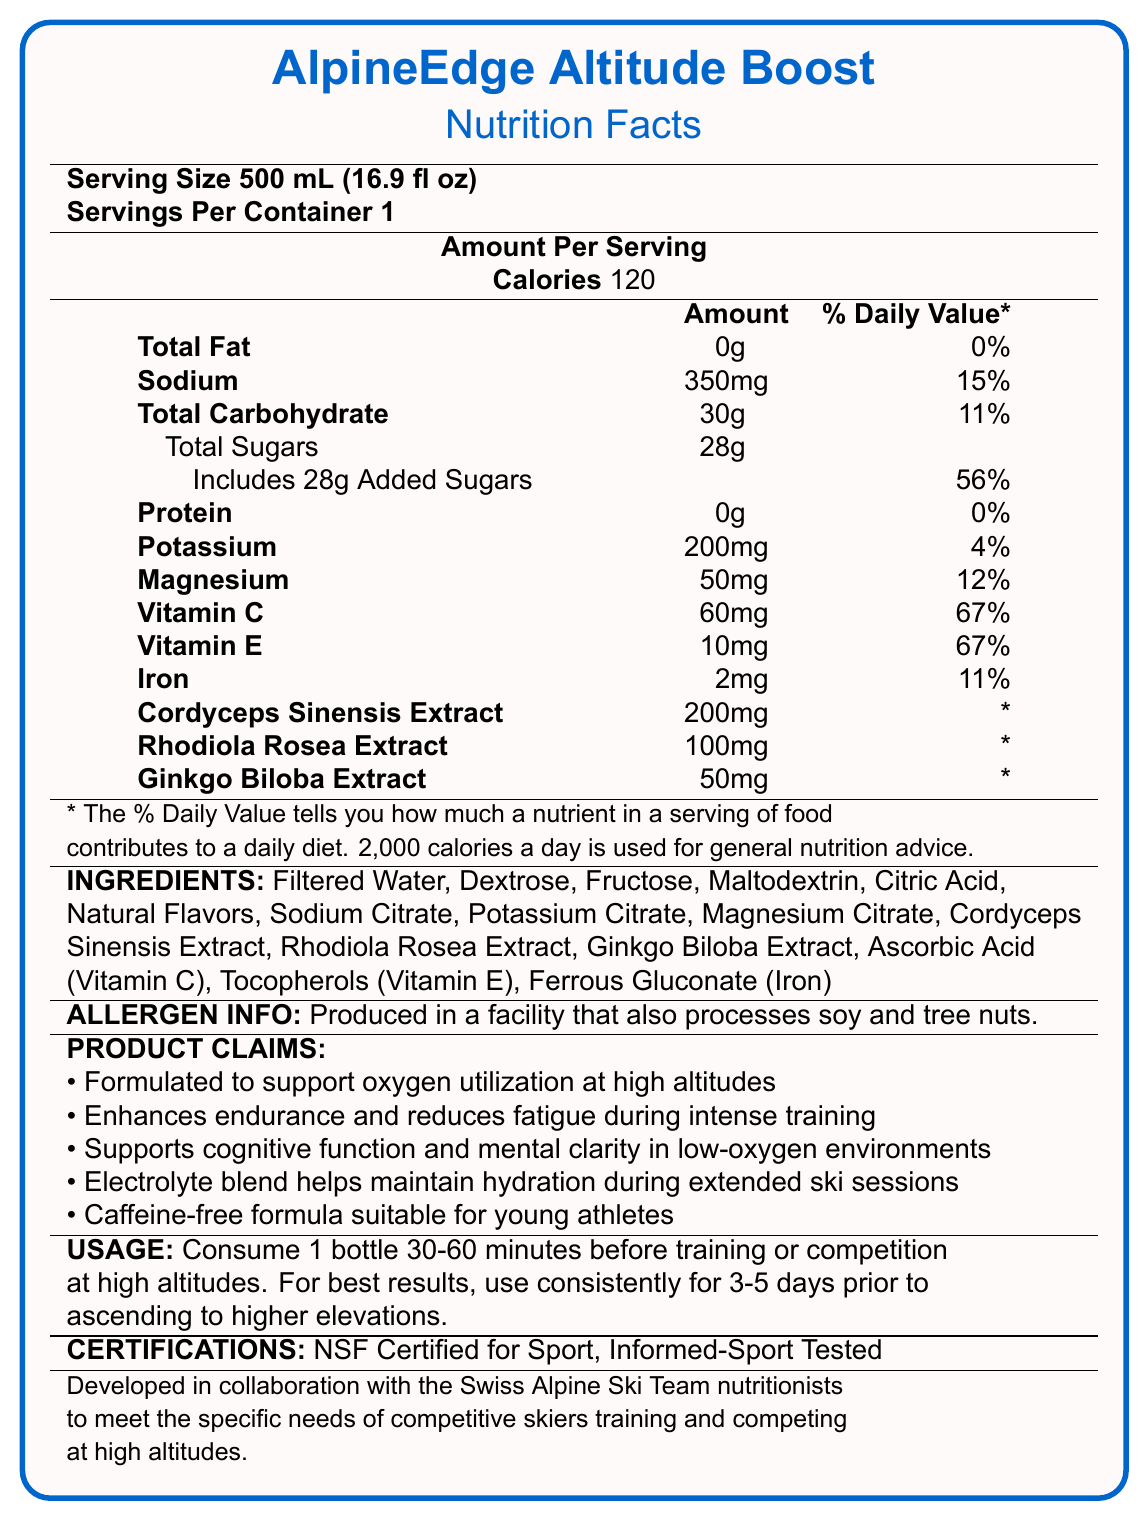what is the product name? The product name, "AlpineEdge Altitude Boost," is displayed prominently at the top of the document.
Answer: AlpineEdge Altitude Boost what is the serving size for this sports drink? The serving size of 500 mL (16.9 fl oz) is mentioned right under the product name in the "Nutrition Facts."
Answer: 500 mL (16.9 fl oz) how many calories are in one serving of this drink? The amount of calories per serving is listed under "Calories," indicating it has 120 calories.
Answer: 120 calories how much sodium does this drink contain? The sodium content is listed in the "Amount Per Serving" section, showing 350mg.
Answer: 350mg what percentage of the daily value does added sugars make up? The "Includes 28g Added Sugars" section indicates that the added sugars make up 56% of the daily value.
Answer: 56% which vitamins are included in this drink? The drink includes Vitamin C (60mg, 67%) and Vitamin E (10mg, 67%), as listed in the "Amount Per Serving" section.
Answer: Vitamin C and Vitamin E how much protein does this sports drink contain? The protein content is listed in the "Amount Per Serving" section, showing 0g.
Answer: 0g which of the following ingredients is not in the drink? A. Dextrose B. High Fructose Corn Syrup C. Citric Acid D. Sodium Citrate The ingredients list does not mention High Fructose Corn Syrup; instead, it includes Dextrose, Citric Acid, and Sodium Citrate.
Answer: B. High Fructose Corn Syrup what percentage of the daily value of iron does this drink provide? A. 4% B. 11% C. 15% D. 20% The "Amount Per Serving" section indicates that the drink provides 11% of the daily value for iron.
Answer: B. 11% is this product suitable for young athletes? The "Product Claims" section includes "Caffeine-free formula suitable for young athletes."
Answer: Yes how should you use this drink for best results? The "Usage Instructions" section provides detailed directions on how to use the drink for best results.
Answer: Consume 1 bottle 30-60 minutes before training or competition at high altitudes. For best results, use consistently for 3-5 days prior to ascending to higher elevations. what is the main idea of this document? The document details the serving size, nutrient content, ingredients, allergen information, product claims, usage instructions, and certifications of the AlpineEdge Altitude Boost sports drink.
Answer: The document provides detailed nutrition information and usage instructions for the AlpineEdge Altitude Boost sports drink, highlighting its benefits for altitude acclimatization and suitability for young athletes. what certifications does this product have? The "Certifications" section lists NSF Certified for Sport and Informed-Sport Tested.
Answer: NSF Certified for Sport, Informed-Sport Tested which ingredient supports cognitive function and mental clarity in low-oxygen environments? The document states that the product supports cognitive function and mental clarity but does not specify which ingredient is responsible for this effect.
Answer: Cannot be determined is this drink produced in a facility that processes soy and tree nuts? The "Allergen Info" section mentions that the product is produced in a facility that processes soy and tree nuts.
Answer: Yes 